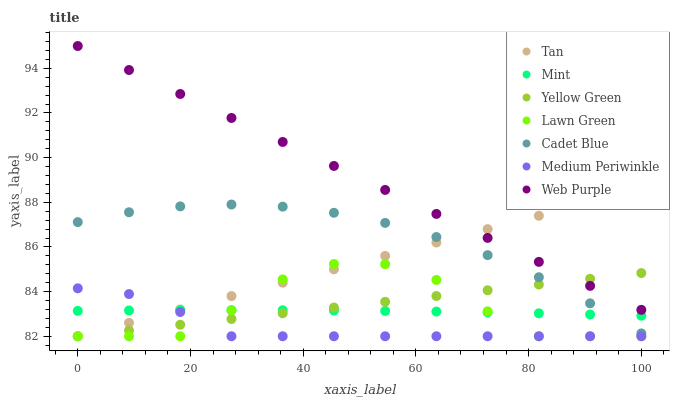Does Medium Periwinkle have the minimum area under the curve?
Answer yes or no. Yes. Does Web Purple have the maximum area under the curve?
Answer yes or no. Yes. Does Cadet Blue have the minimum area under the curve?
Answer yes or no. No. Does Cadet Blue have the maximum area under the curve?
Answer yes or no. No. Is Web Purple the smoothest?
Answer yes or no. Yes. Is Lawn Green the roughest?
Answer yes or no. Yes. Is Cadet Blue the smoothest?
Answer yes or no. No. Is Cadet Blue the roughest?
Answer yes or no. No. Does Lawn Green have the lowest value?
Answer yes or no. Yes. Does Cadet Blue have the lowest value?
Answer yes or no. No. Does Web Purple have the highest value?
Answer yes or no. Yes. Does Cadet Blue have the highest value?
Answer yes or no. No. Is Lawn Green less than Cadet Blue?
Answer yes or no. Yes. Is Web Purple greater than Lawn Green?
Answer yes or no. Yes. Does Cadet Blue intersect Yellow Green?
Answer yes or no. Yes. Is Cadet Blue less than Yellow Green?
Answer yes or no. No. Is Cadet Blue greater than Yellow Green?
Answer yes or no. No. Does Lawn Green intersect Cadet Blue?
Answer yes or no. No. 